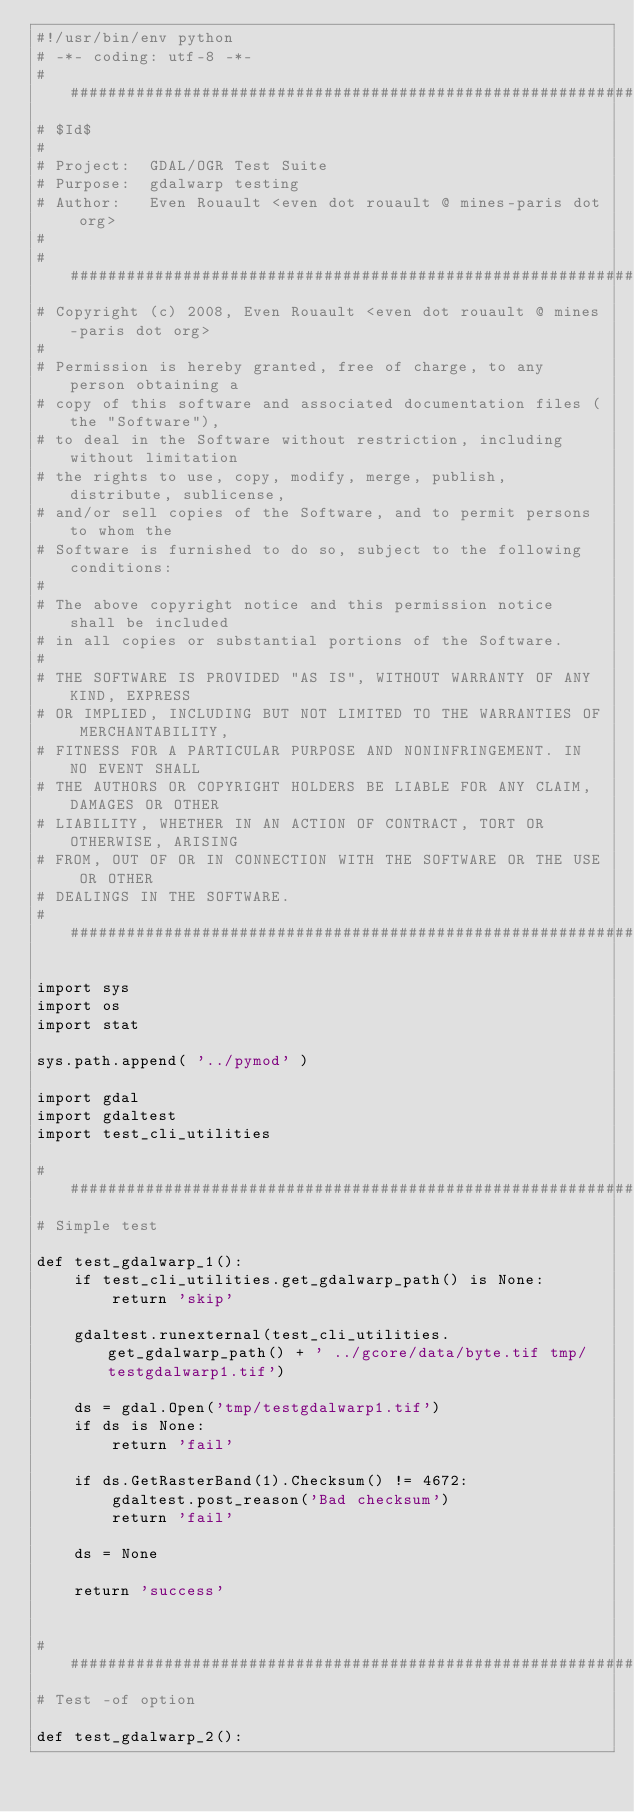<code> <loc_0><loc_0><loc_500><loc_500><_Python_>#!/usr/bin/env python
# -*- coding: utf-8 -*-
###############################################################################
# $Id$
#
# Project:  GDAL/OGR Test Suite
# Purpose:  gdalwarp testing
# Author:   Even Rouault <even dot rouault @ mines-paris dot org>
# 
###############################################################################
# Copyright (c) 2008, Even Rouault <even dot rouault @ mines-paris dot org>
# 
# Permission is hereby granted, free of charge, to any person obtaining a
# copy of this software and associated documentation files (the "Software"),
# to deal in the Software without restriction, including without limitation
# the rights to use, copy, modify, merge, publish, distribute, sublicense,
# and/or sell copies of the Software, and to permit persons to whom the
# Software is furnished to do so, subject to the following conditions:
#
# The above copyright notice and this permission notice shall be included
# in all copies or substantial portions of the Software.
# 
# THE SOFTWARE IS PROVIDED "AS IS", WITHOUT WARRANTY OF ANY KIND, EXPRESS
# OR IMPLIED, INCLUDING BUT NOT LIMITED TO THE WARRANTIES OF MERCHANTABILITY,
# FITNESS FOR A PARTICULAR PURPOSE AND NONINFRINGEMENT. IN NO EVENT SHALL
# THE AUTHORS OR COPYRIGHT HOLDERS BE LIABLE FOR ANY CLAIM, DAMAGES OR OTHER
# LIABILITY, WHETHER IN AN ACTION OF CONTRACT, TORT OR OTHERWISE, ARISING
# FROM, OUT OF OR IN CONNECTION WITH THE SOFTWARE OR THE USE OR OTHER
# DEALINGS IN THE SOFTWARE.
###############################################################################

import sys
import os
import stat

sys.path.append( '../pymod' )

import gdal
import gdaltest
import test_cli_utilities

###############################################################################
# Simple test

def test_gdalwarp_1():
    if test_cli_utilities.get_gdalwarp_path() is None:
        return 'skip'

    gdaltest.runexternal(test_cli_utilities.get_gdalwarp_path() + ' ../gcore/data/byte.tif tmp/testgdalwarp1.tif')

    ds = gdal.Open('tmp/testgdalwarp1.tif')
    if ds is None:
        return 'fail'

    if ds.GetRasterBand(1).Checksum() != 4672:
        gdaltest.post_reason('Bad checksum')
        return 'fail'

    ds = None

    return 'success'


###############################################################################
# Test -of option

def test_gdalwarp_2():</code> 